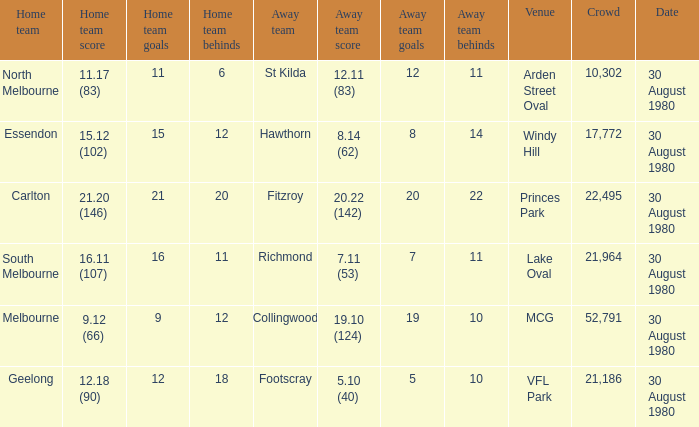What is the home team score at lake oval? 16.11 (107). 